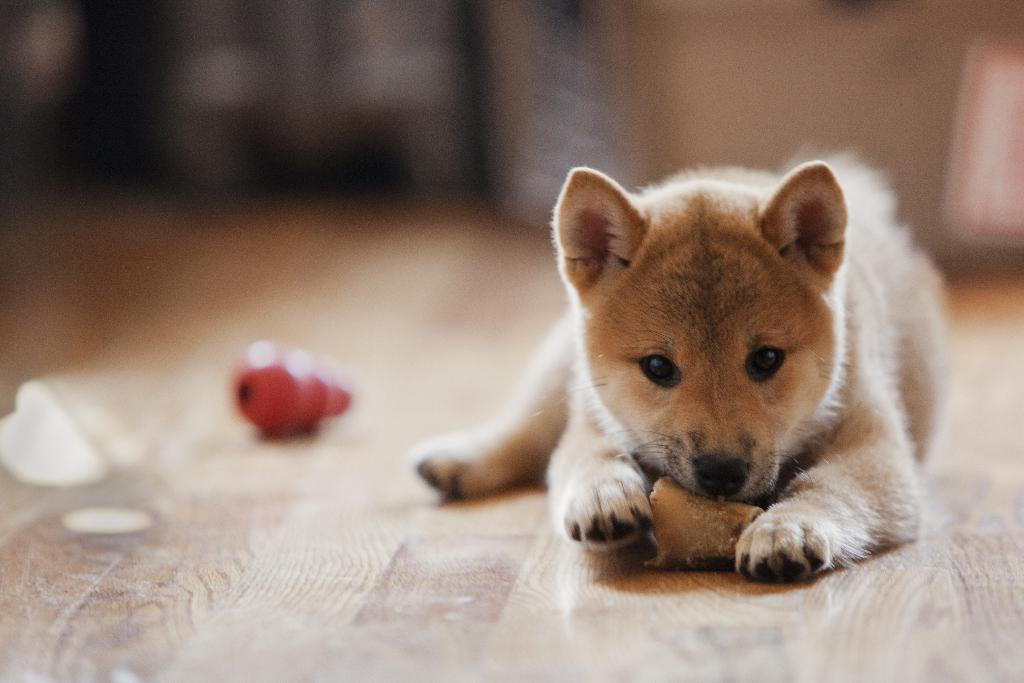What animal can be seen in the image? There is a dog in the image. What is the dog doing in the image? The dog is eating food. What type of flooring is visible in the image? The floor is made of wood. Can you describe the background of the image? The background of the image is blurred. What type of grain is being used as an example in the image? There is no grain present in the image. 